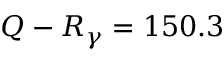Convert formula to latex. <formula><loc_0><loc_0><loc_500><loc_500>Q - R _ { \gamma } = 1 5 0 . 3</formula> 